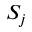<formula> <loc_0><loc_0><loc_500><loc_500>S _ { j }</formula> 